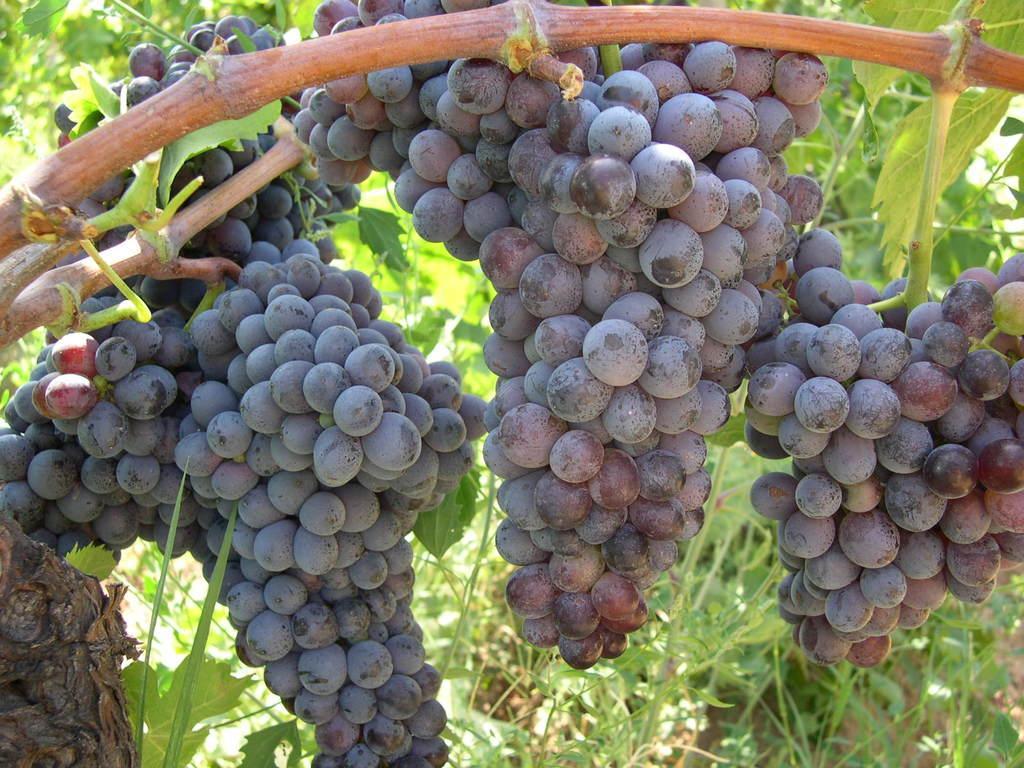Describe this image in one or two sentences. Here in this picture we can see bunches of grapes hanging on a tree and we can also see plants present. 